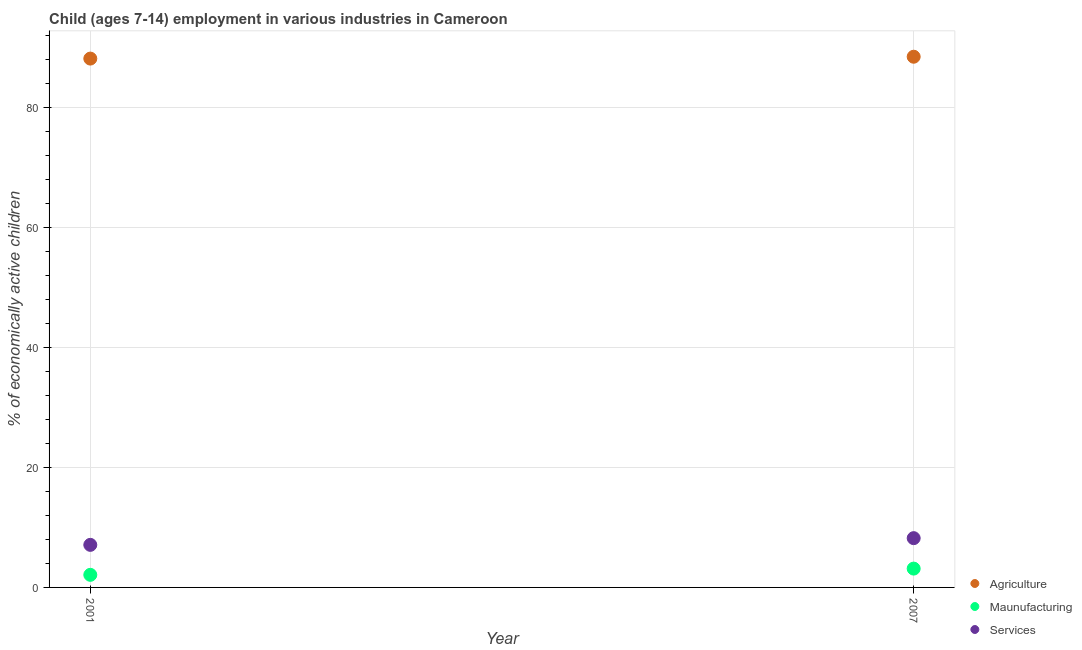How many different coloured dotlines are there?
Your answer should be compact. 3. What is the percentage of economically active children in services in 2007?
Your response must be concise. 8.22. Across all years, what is the maximum percentage of economically active children in agriculture?
Ensure brevity in your answer.  88.52. Across all years, what is the minimum percentage of economically active children in manufacturing?
Your answer should be very brief. 2.1. In which year was the percentage of economically active children in services maximum?
Your answer should be very brief. 2007. What is the total percentage of economically active children in agriculture in the graph?
Your answer should be very brief. 176.73. What is the difference between the percentage of economically active children in agriculture in 2001 and that in 2007?
Ensure brevity in your answer.  -0.31. What is the difference between the percentage of economically active children in manufacturing in 2007 and the percentage of economically active children in agriculture in 2001?
Give a very brief answer. -85.07. What is the average percentage of economically active children in agriculture per year?
Provide a succinct answer. 88.36. In the year 2007, what is the difference between the percentage of economically active children in services and percentage of economically active children in manufacturing?
Offer a terse response. 5.08. What is the ratio of the percentage of economically active children in services in 2001 to that in 2007?
Provide a succinct answer. 0.86. Is the percentage of economically active children in agriculture in 2001 less than that in 2007?
Give a very brief answer. Yes. In how many years, is the percentage of economically active children in services greater than the average percentage of economically active children in services taken over all years?
Provide a short and direct response. 1. Does the percentage of economically active children in services monotonically increase over the years?
Your response must be concise. Yes. How many dotlines are there?
Offer a very short reply. 3. How many years are there in the graph?
Make the answer very short. 2. Does the graph contain any zero values?
Make the answer very short. No. Where does the legend appear in the graph?
Your answer should be compact. Bottom right. How many legend labels are there?
Provide a succinct answer. 3. How are the legend labels stacked?
Keep it short and to the point. Vertical. What is the title of the graph?
Your answer should be compact. Child (ages 7-14) employment in various industries in Cameroon. What is the label or title of the X-axis?
Ensure brevity in your answer.  Year. What is the label or title of the Y-axis?
Your answer should be very brief. % of economically active children. What is the % of economically active children in Agriculture in 2001?
Your answer should be very brief. 88.21. What is the % of economically active children in Agriculture in 2007?
Your response must be concise. 88.52. What is the % of economically active children in Maunufacturing in 2007?
Make the answer very short. 3.14. What is the % of economically active children in Services in 2007?
Your response must be concise. 8.22. Across all years, what is the maximum % of economically active children of Agriculture?
Your answer should be very brief. 88.52. Across all years, what is the maximum % of economically active children of Maunufacturing?
Provide a short and direct response. 3.14. Across all years, what is the maximum % of economically active children in Services?
Make the answer very short. 8.22. Across all years, what is the minimum % of economically active children in Agriculture?
Ensure brevity in your answer.  88.21. Across all years, what is the minimum % of economically active children in Maunufacturing?
Offer a very short reply. 2.1. Across all years, what is the minimum % of economically active children in Services?
Your response must be concise. 7.1. What is the total % of economically active children in Agriculture in the graph?
Offer a very short reply. 176.73. What is the total % of economically active children of Maunufacturing in the graph?
Make the answer very short. 5.24. What is the total % of economically active children of Services in the graph?
Your response must be concise. 15.32. What is the difference between the % of economically active children in Agriculture in 2001 and that in 2007?
Keep it short and to the point. -0.31. What is the difference between the % of economically active children in Maunufacturing in 2001 and that in 2007?
Your response must be concise. -1.04. What is the difference between the % of economically active children in Services in 2001 and that in 2007?
Make the answer very short. -1.12. What is the difference between the % of economically active children in Agriculture in 2001 and the % of economically active children in Maunufacturing in 2007?
Give a very brief answer. 85.07. What is the difference between the % of economically active children of Agriculture in 2001 and the % of economically active children of Services in 2007?
Your response must be concise. 79.99. What is the difference between the % of economically active children of Maunufacturing in 2001 and the % of economically active children of Services in 2007?
Provide a succinct answer. -6.12. What is the average % of economically active children of Agriculture per year?
Give a very brief answer. 88.36. What is the average % of economically active children of Maunufacturing per year?
Provide a short and direct response. 2.62. What is the average % of economically active children of Services per year?
Your answer should be very brief. 7.66. In the year 2001, what is the difference between the % of economically active children of Agriculture and % of economically active children of Maunufacturing?
Ensure brevity in your answer.  86.11. In the year 2001, what is the difference between the % of economically active children of Agriculture and % of economically active children of Services?
Your answer should be compact. 81.11. In the year 2007, what is the difference between the % of economically active children of Agriculture and % of economically active children of Maunufacturing?
Provide a succinct answer. 85.38. In the year 2007, what is the difference between the % of economically active children of Agriculture and % of economically active children of Services?
Give a very brief answer. 80.3. In the year 2007, what is the difference between the % of economically active children of Maunufacturing and % of economically active children of Services?
Provide a succinct answer. -5.08. What is the ratio of the % of economically active children of Maunufacturing in 2001 to that in 2007?
Your answer should be compact. 0.67. What is the ratio of the % of economically active children of Services in 2001 to that in 2007?
Your answer should be very brief. 0.86. What is the difference between the highest and the second highest % of economically active children of Agriculture?
Provide a succinct answer. 0.31. What is the difference between the highest and the second highest % of economically active children in Services?
Keep it short and to the point. 1.12. What is the difference between the highest and the lowest % of economically active children of Agriculture?
Provide a short and direct response. 0.31. What is the difference between the highest and the lowest % of economically active children of Maunufacturing?
Offer a terse response. 1.04. What is the difference between the highest and the lowest % of economically active children in Services?
Your answer should be very brief. 1.12. 